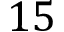Convert formula to latex. <formula><loc_0><loc_0><loc_500><loc_500>1 5</formula> 